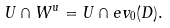<formula> <loc_0><loc_0><loc_500><loc_500>U \cap W ^ { u } = U \cap e v _ { 0 } ( D ) .</formula> 